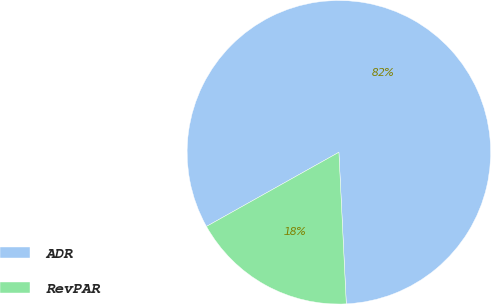<chart> <loc_0><loc_0><loc_500><loc_500><pie_chart><fcel>ADR<fcel>RevPAR<nl><fcel>82.35%<fcel>17.65%<nl></chart> 